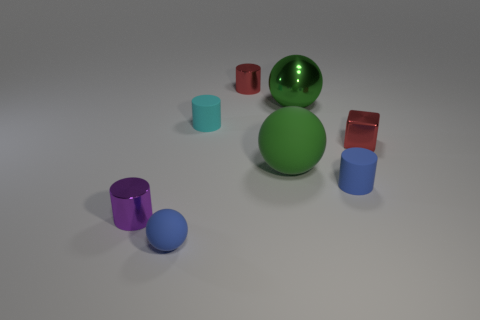Subtract 1 cylinders. How many cylinders are left? 3 Subtract all brown balls. Subtract all blue cubes. How many balls are left? 3 Add 1 shiny cubes. How many objects exist? 9 Subtract all spheres. How many objects are left? 5 Subtract 0 yellow spheres. How many objects are left? 8 Subtract all cyan rubber cylinders. Subtract all big green balls. How many objects are left? 5 Add 1 tiny cyan matte things. How many tiny cyan matte things are left? 2 Add 5 tiny blue objects. How many tiny blue objects exist? 7 